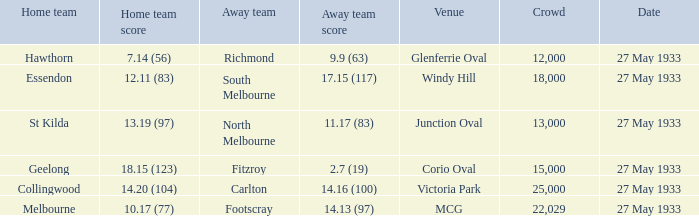In the match where the home team scored 14.20 (104), how many attendees were in the crowd? 25000.0. 